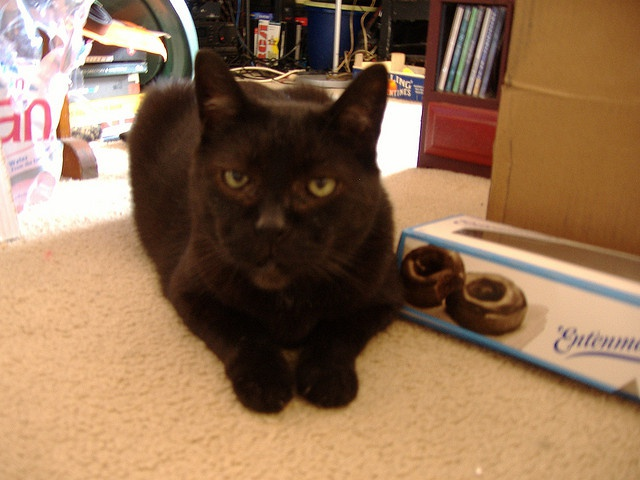Describe the objects in this image and their specific colors. I can see cat in lightpink, black, maroon, and tan tones, donut in lightpink, black, maroon, and olive tones, donut in lightpink, black, maroon, and brown tones, book in lightpink, white, gray, darkgray, and lightblue tones, and book in lightpink, tan, and gray tones in this image. 